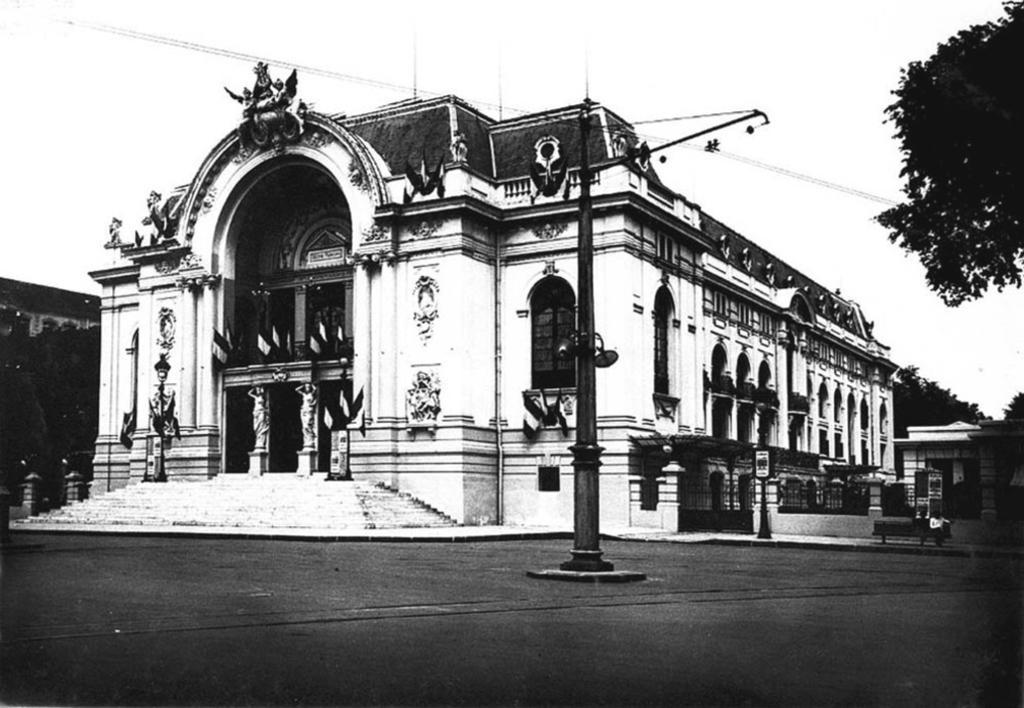Describe this image in one or two sentences. This image is taken outdoors. This image is a black and white image. At the bottom of the image there is a floor. At the top of the image there is the sky. In the background there is a building and there are a few trees. On the right side of the image there is a tree and there is a house. There is a railing. There is an empty bench on the sidewalk. In the middle of the image there is a building with walls, windows, pillars, railings, balconies, roofs and carvings on it. There are a few sculptures on the walls. There are a few statues and there are a few flags. There is a pole with a street light. There are a few stairs. 